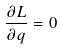Convert formula to latex. <formula><loc_0><loc_0><loc_500><loc_500>\frac { \partial L } { \partial q } = 0</formula> 